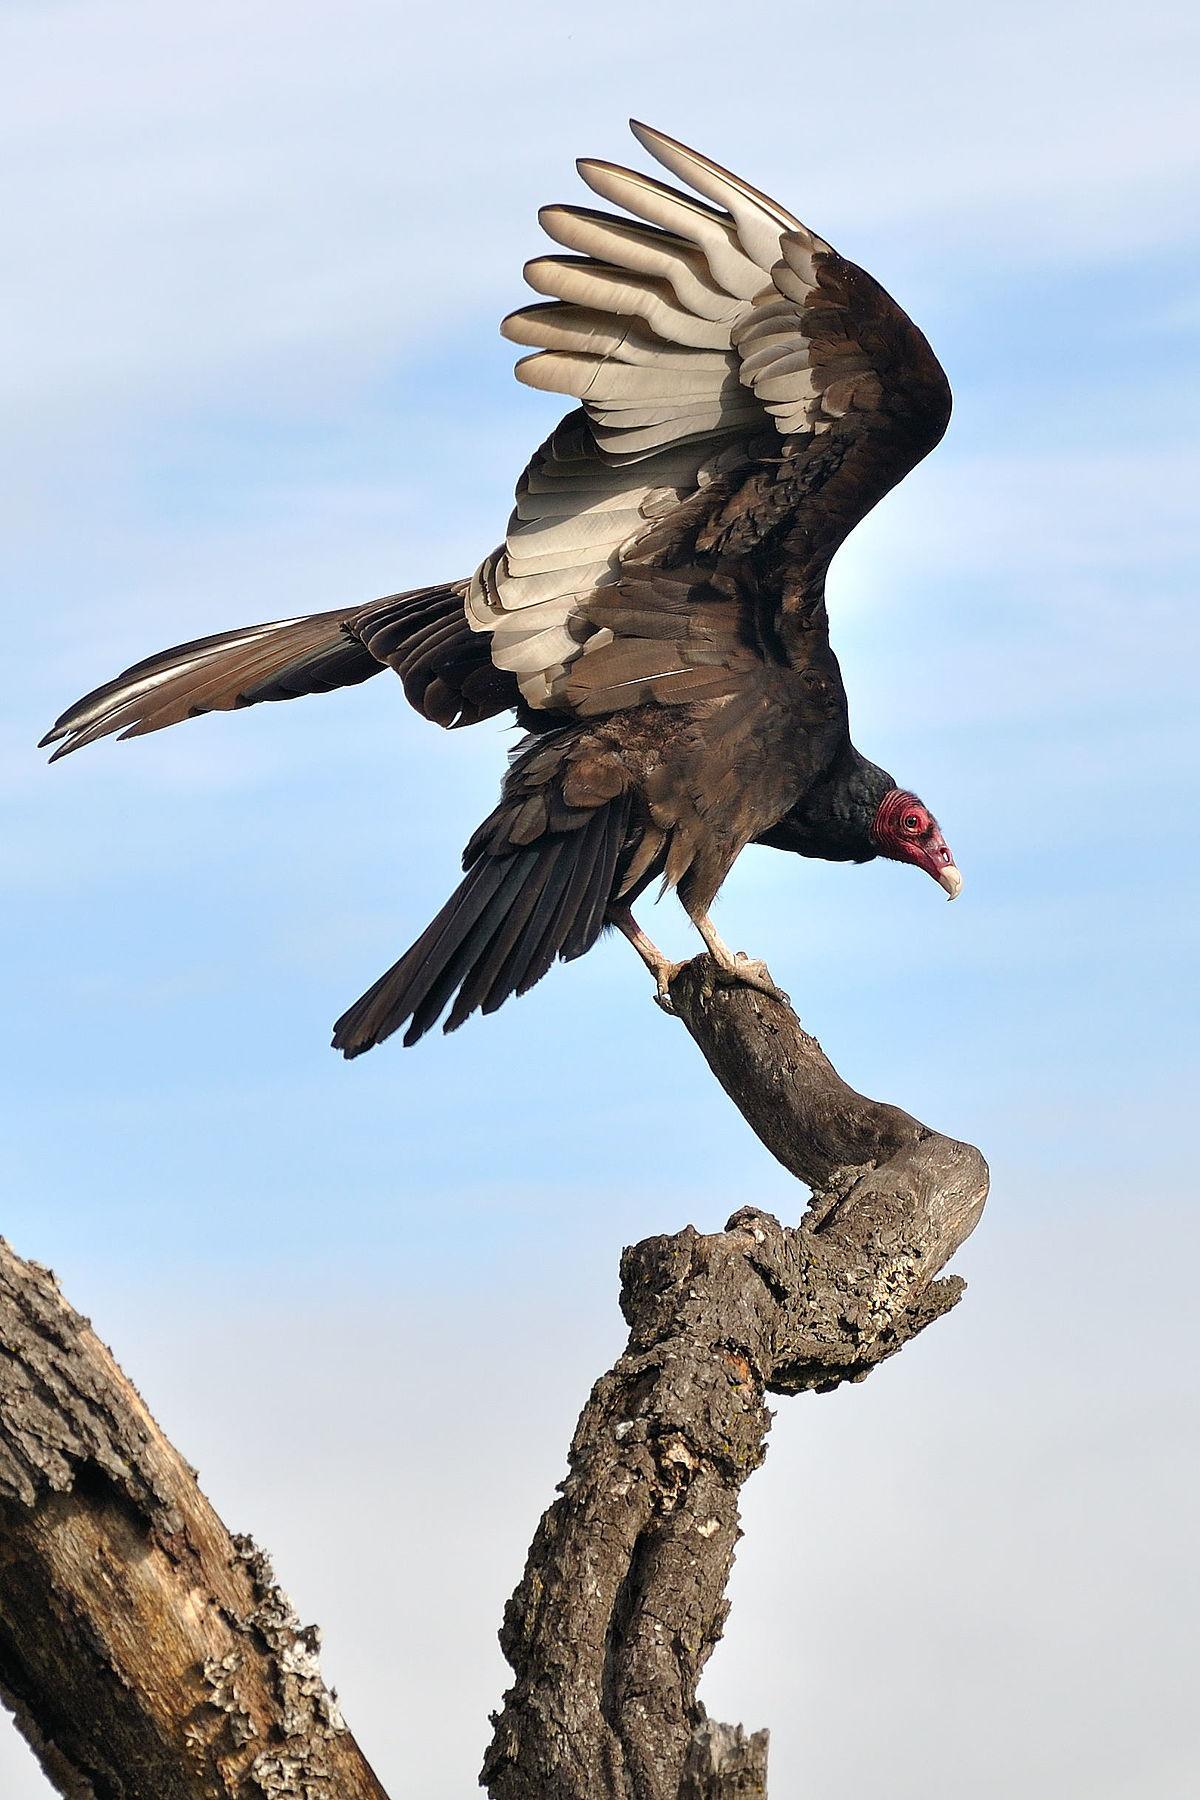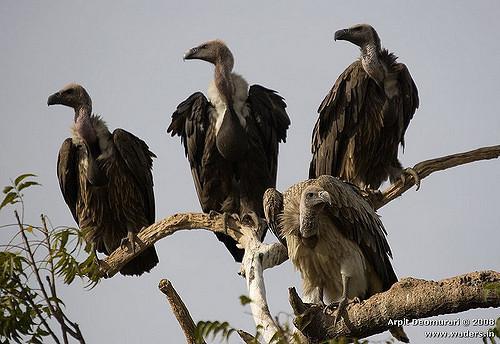The first image is the image on the left, the second image is the image on the right. Assess this claim about the two images: "At least one bird is flying in the air.". Correct or not? Answer yes or no. No. 